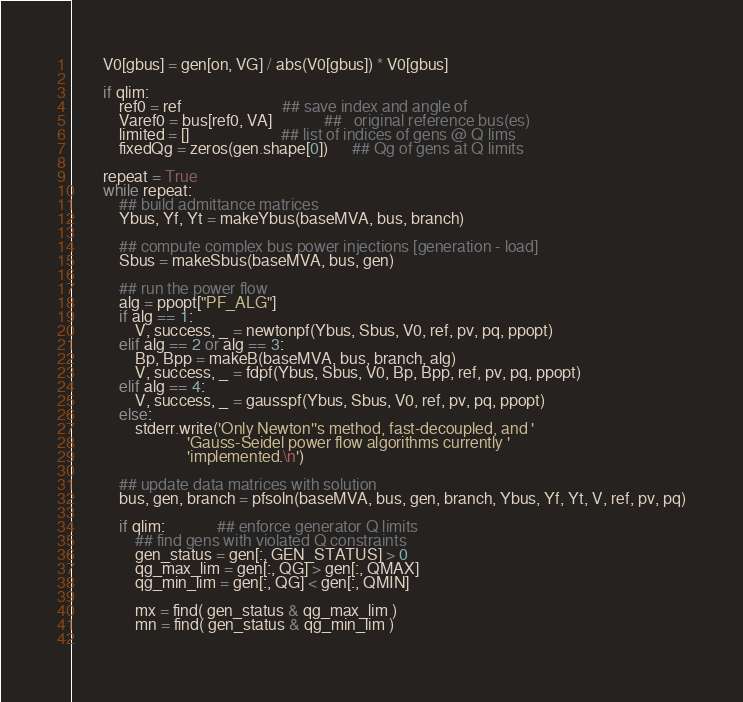<code> <loc_0><loc_0><loc_500><loc_500><_Python_>        V0[gbus] = gen[on, VG] / abs(V0[gbus]) * V0[gbus]

        if qlim:
            ref0 = ref                         ## save index and angle of
            Varef0 = bus[ref0, VA]             ##   original reference bus(es)
            limited = []                       ## list of indices of gens @ Q lims
            fixedQg = zeros(gen.shape[0])      ## Qg of gens at Q limits

        repeat = True
        while repeat:
            ## build admittance matrices
            Ybus, Yf, Yt = makeYbus(baseMVA, bus, branch)

            ## compute complex bus power injections [generation - load]
            Sbus = makeSbus(baseMVA, bus, gen)

            ## run the power flow
            alg = ppopt["PF_ALG"]
            if alg == 1:
                V, success, _ = newtonpf(Ybus, Sbus, V0, ref, pv, pq, ppopt)
            elif alg == 2 or alg == 3:
                Bp, Bpp = makeB(baseMVA, bus, branch, alg)
                V, success, _ = fdpf(Ybus, Sbus, V0, Bp, Bpp, ref, pv, pq, ppopt)
            elif alg == 4:
                V, success, _ = gausspf(Ybus, Sbus, V0, ref, pv, pq, ppopt)
            else:
                stderr.write('Only Newton''s method, fast-decoupled, and '
                             'Gauss-Seidel power flow algorithms currently '
                             'implemented.\n')

            ## update data matrices with solution
            bus, gen, branch = pfsoln(baseMVA, bus, gen, branch, Ybus, Yf, Yt, V, ref, pv, pq)

            if qlim:             ## enforce generator Q limits
                ## find gens with violated Q constraints
                gen_status = gen[:, GEN_STATUS] > 0
                qg_max_lim = gen[:, QG] > gen[:, QMAX]
                qg_min_lim = gen[:, QG] < gen[:, QMIN]
                
                mx = find( gen_status & qg_max_lim )
                mn = find( gen_status & qg_min_lim )
                </code> 